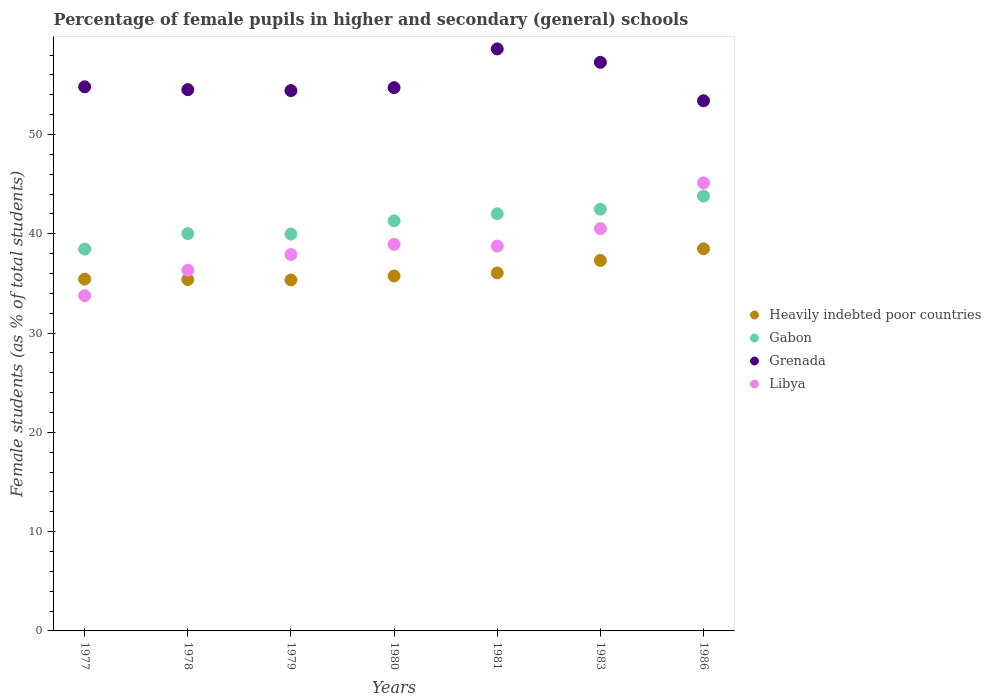Is the number of dotlines equal to the number of legend labels?
Give a very brief answer. Yes. What is the percentage of female pupils in higher and secondary schools in Gabon in 1986?
Keep it short and to the point. 43.79. Across all years, what is the maximum percentage of female pupils in higher and secondary schools in Libya?
Keep it short and to the point. 45.12. Across all years, what is the minimum percentage of female pupils in higher and secondary schools in Gabon?
Offer a very short reply. 38.45. In which year was the percentage of female pupils in higher and secondary schools in Libya minimum?
Give a very brief answer. 1977. What is the total percentage of female pupils in higher and secondary schools in Heavily indebted poor countries in the graph?
Your answer should be very brief. 253.76. What is the difference between the percentage of female pupils in higher and secondary schools in Libya in 1979 and that in 1981?
Ensure brevity in your answer.  -0.85. What is the difference between the percentage of female pupils in higher and secondary schools in Gabon in 1986 and the percentage of female pupils in higher and secondary schools in Grenada in 1977?
Your answer should be very brief. -11.01. What is the average percentage of female pupils in higher and secondary schools in Gabon per year?
Provide a succinct answer. 41.14. In the year 1986, what is the difference between the percentage of female pupils in higher and secondary schools in Grenada and percentage of female pupils in higher and secondary schools in Heavily indebted poor countries?
Your answer should be very brief. 14.9. In how many years, is the percentage of female pupils in higher and secondary schools in Heavily indebted poor countries greater than 2 %?
Your response must be concise. 7. What is the ratio of the percentage of female pupils in higher and secondary schools in Libya in 1979 to that in 1986?
Make the answer very short. 0.84. What is the difference between the highest and the second highest percentage of female pupils in higher and secondary schools in Heavily indebted poor countries?
Offer a very short reply. 1.17. What is the difference between the highest and the lowest percentage of female pupils in higher and secondary schools in Libya?
Give a very brief answer. 11.36. In how many years, is the percentage of female pupils in higher and secondary schools in Gabon greater than the average percentage of female pupils in higher and secondary schools in Gabon taken over all years?
Keep it short and to the point. 4. Is it the case that in every year, the sum of the percentage of female pupils in higher and secondary schools in Gabon and percentage of female pupils in higher and secondary schools in Libya  is greater than the sum of percentage of female pupils in higher and secondary schools in Heavily indebted poor countries and percentage of female pupils in higher and secondary schools in Grenada?
Provide a succinct answer. Yes. Is it the case that in every year, the sum of the percentage of female pupils in higher and secondary schools in Gabon and percentage of female pupils in higher and secondary schools in Heavily indebted poor countries  is greater than the percentage of female pupils in higher and secondary schools in Libya?
Your answer should be very brief. Yes. Does the percentage of female pupils in higher and secondary schools in Heavily indebted poor countries monotonically increase over the years?
Your answer should be very brief. No. Is the percentage of female pupils in higher and secondary schools in Heavily indebted poor countries strictly less than the percentage of female pupils in higher and secondary schools in Gabon over the years?
Provide a short and direct response. Yes. How many dotlines are there?
Make the answer very short. 4. What is the difference between two consecutive major ticks on the Y-axis?
Offer a terse response. 10. Does the graph contain any zero values?
Provide a succinct answer. No. Does the graph contain grids?
Give a very brief answer. No. How many legend labels are there?
Ensure brevity in your answer.  4. How are the legend labels stacked?
Make the answer very short. Vertical. What is the title of the graph?
Offer a terse response. Percentage of female pupils in higher and secondary (general) schools. Does "Greece" appear as one of the legend labels in the graph?
Make the answer very short. No. What is the label or title of the X-axis?
Offer a terse response. Years. What is the label or title of the Y-axis?
Offer a very short reply. Female students (as % of total students). What is the Female students (as % of total students) in Heavily indebted poor countries in 1977?
Make the answer very short. 35.43. What is the Female students (as % of total students) of Gabon in 1977?
Your answer should be very brief. 38.45. What is the Female students (as % of total students) of Grenada in 1977?
Provide a short and direct response. 54.8. What is the Female students (as % of total students) of Libya in 1977?
Keep it short and to the point. 33.76. What is the Female students (as % of total students) in Heavily indebted poor countries in 1978?
Ensure brevity in your answer.  35.39. What is the Female students (as % of total students) of Gabon in 1978?
Keep it short and to the point. 40.02. What is the Female students (as % of total students) of Grenada in 1978?
Your answer should be compact. 54.51. What is the Female students (as % of total students) in Libya in 1978?
Offer a terse response. 36.33. What is the Female students (as % of total students) in Heavily indebted poor countries in 1979?
Provide a succinct answer. 35.35. What is the Female students (as % of total students) of Gabon in 1979?
Make the answer very short. 39.97. What is the Female students (as % of total students) in Grenada in 1979?
Offer a very short reply. 54.41. What is the Female students (as % of total students) of Libya in 1979?
Your answer should be compact. 37.91. What is the Female students (as % of total students) of Heavily indebted poor countries in 1980?
Give a very brief answer. 35.75. What is the Female students (as % of total students) in Gabon in 1980?
Make the answer very short. 41.3. What is the Female students (as % of total students) in Grenada in 1980?
Offer a terse response. 54.71. What is the Female students (as % of total students) in Libya in 1980?
Make the answer very short. 38.93. What is the Female students (as % of total students) in Heavily indebted poor countries in 1981?
Offer a terse response. 36.05. What is the Female students (as % of total students) in Gabon in 1981?
Ensure brevity in your answer.  42.01. What is the Female students (as % of total students) of Grenada in 1981?
Provide a succinct answer. 58.61. What is the Female students (as % of total students) in Libya in 1981?
Your answer should be compact. 38.76. What is the Female students (as % of total students) in Heavily indebted poor countries in 1983?
Offer a terse response. 37.31. What is the Female students (as % of total students) in Gabon in 1983?
Ensure brevity in your answer.  42.47. What is the Female students (as % of total students) of Grenada in 1983?
Give a very brief answer. 57.26. What is the Female students (as % of total students) of Libya in 1983?
Your answer should be very brief. 40.51. What is the Female students (as % of total students) in Heavily indebted poor countries in 1986?
Your answer should be compact. 38.49. What is the Female students (as % of total students) in Gabon in 1986?
Provide a succinct answer. 43.79. What is the Female students (as % of total students) in Grenada in 1986?
Your response must be concise. 53.39. What is the Female students (as % of total students) in Libya in 1986?
Keep it short and to the point. 45.12. Across all years, what is the maximum Female students (as % of total students) in Heavily indebted poor countries?
Your answer should be very brief. 38.49. Across all years, what is the maximum Female students (as % of total students) of Gabon?
Your response must be concise. 43.79. Across all years, what is the maximum Female students (as % of total students) in Grenada?
Keep it short and to the point. 58.61. Across all years, what is the maximum Female students (as % of total students) in Libya?
Provide a succinct answer. 45.12. Across all years, what is the minimum Female students (as % of total students) in Heavily indebted poor countries?
Offer a terse response. 35.35. Across all years, what is the minimum Female students (as % of total students) of Gabon?
Provide a short and direct response. 38.45. Across all years, what is the minimum Female students (as % of total students) in Grenada?
Offer a terse response. 53.39. Across all years, what is the minimum Female students (as % of total students) of Libya?
Offer a terse response. 33.76. What is the total Female students (as % of total students) of Heavily indebted poor countries in the graph?
Provide a succinct answer. 253.76. What is the total Female students (as % of total students) in Gabon in the graph?
Provide a short and direct response. 288.01. What is the total Female students (as % of total students) of Grenada in the graph?
Your answer should be compact. 387.7. What is the total Female students (as % of total students) in Libya in the graph?
Keep it short and to the point. 271.32. What is the difference between the Female students (as % of total students) in Heavily indebted poor countries in 1977 and that in 1978?
Ensure brevity in your answer.  0.04. What is the difference between the Female students (as % of total students) of Gabon in 1977 and that in 1978?
Offer a terse response. -1.56. What is the difference between the Female students (as % of total students) in Grenada in 1977 and that in 1978?
Provide a succinct answer. 0.29. What is the difference between the Female students (as % of total students) in Libya in 1977 and that in 1978?
Make the answer very short. -2.56. What is the difference between the Female students (as % of total students) in Heavily indebted poor countries in 1977 and that in 1979?
Your answer should be very brief. 0.08. What is the difference between the Female students (as % of total students) of Gabon in 1977 and that in 1979?
Offer a very short reply. -1.51. What is the difference between the Female students (as % of total students) of Grenada in 1977 and that in 1979?
Provide a short and direct response. 0.38. What is the difference between the Female students (as % of total students) in Libya in 1977 and that in 1979?
Your response must be concise. -4.14. What is the difference between the Female students (as % of total students) in Heavily indebted poor countries in 1977 and that in 1980?
Provide a succinct answer. -0.32. What is the difference between the Female students (as % of total students) of Gabon in 1977 and that in 1980?
Your response must be concise. -2.84. What is the difference between the Female students (as % of total students) of Grenada in 1977 and that in 1980?
Provide a short and direct response. 0.09. What is the difference between the Female students (as % of total students) of Libya in 1977 and that in 1980?
Offer a terse response. -5.17. What is the difference between the Female students (as % of total students) of Heavily indebted poor countries in 1977 and that in 1981?
Provide a short and direct response. -0.62. What is the difference between the Female students (as % of total students) of Gabon in 1977 and that in 1981?
Keep it short and to the point. -3.56. What is the difference between the Female students (as % of total students) of Grenada in 1977 and that in 1981?
Keep it short and to the point. -3.82. What is the difference between the Female students (as % of total students) of Libya in 1977 and that in 1981?
Give a very brief answer. -4.99. What is the difference between the Female students (as % of total students) in Heavily indebted poor countries in 1977 and that in 1983?
Give a very brief answer. -1.88. What is the difference between the Female students (as % of total students) of Gabon in 1977 and that in 1983?
Ensure brevity in your answer.  -4.02. What is the difference between the Female students (as % of total students) of Grenada in 1977 and that in 1983?
Your answer should be compact. -2.46. What is the difference between the Female students (as % of total students) of Libya in 1977 and that in 1983?
Your answer should be very brief. -6.75. What is the difference between the Female students (as % of total students) of Heavily indebted poor countries in 1977 and that in 1986?
Give a very brief answer. -3.06. What is the difference between the Female students (as % of total students) of Gabon in 1977 and that in 1986?
Make the answer very short. -5.34. What is the difference between the Female students (as % of total students) in Grenada in 1977 and that in 1986?
Offer a very short reply. 1.41. What is the difference between the Female students (as % of total students) of Libya in 1977 and that in 1986?
Make the answer very short. -11.36. What is the difference between the Female students (as % of total students) of Heavily indebted poor countries in 1978 and that in 1979?
Your response must be concise. 0.04. What is the difference between the Female students (as % of total students) in Gabon in 1978 and that in 1979?
Give a very brief answer. 0.05. What is the difference between the Female students (as % of total students) in Grenada in 1978 and that in 1979?
Offer a very short reply. 0.1. What is the difference between the Female students (as % of total students) of Libya in 1978 and that in 1979?
Your answer should be very brief. -1.58. What is the difference between the Female students (as % of total students) of Heavily indebted poor countries in 1978 and that in 1980?
Your answer should be compact. -0.36. What is the difference between the Female students (as % of total students) of Gabon in 1978 and that in 1980?
Give a very brief answer. -1.28. What is the difference between the Female students (as % of total students) of Grenada in 1978 and that in 1980?
Provide a short and direct response. -0.2. What is the difference between the Female students (as % of total students) of Libya in 1978 and that in 1980?
Your response must be concise. -2.61. What is the difference between the Female students (as % of total students) of Heavily indebted poor countries in 1978 and that in 1981?
Offer a very short reply. -0.66. What is the difference between the Female students (as % of total students) of Gabon in 1978 and that in 1981?
Offer a terse response. -2. What is the difference between the Female students (as % of total students) of Grenada in 1978 and that in 1981?
Ensure brevity in your answer.  -4.1. What is the difference between the Female students (as % of total students) of Libya in 1978 and that in 1981?
Your answer should be very brief. -2.43. What is the difference between the Female students (as % of total students) of Heavily indebted poor countries in 1978 and that in 1983?
Ensure brevity in your answer.  -1.92. What is the difference between the Female students (as % of total students) of Gabon in 1978 and that in 1983?
Make the answer very short. -2.45. What is the difference between the Female students (as % of total students) in Grenada in 1978 and that in 1983?
Your response must be concise. -2.75. What is the difference between the Female students (as % of total students) in Libya in 1978 and that in 1983?
Provide a short and direct response. -4.19. What is the difference between the Female students (as % of total students) in Heavily indebted poor countries in 1978 and that in 1986?
Keep it short and to the point. -3.1. What is the difference between the Female students (as % of total students) of Gabon in 1978 and that in 1986?
Your response must be concise. -3.78. What is the difference between the Female students (as % of total students) in Grenada in 1978 and that in 1986?
Ensure brevity in your answer.  1.12. What is the difference between the Female students (as % of total students) of Libya in 1978 and that in 1986?
Your answer should be compact. -8.8. What is the difference between the Female students (as % of total students) in Heavily indebted poor countries in 1979 and that in 1980?
Offer a very short reply. -0.4. What is the difference between the Female students (as % of total students) of Gabon in 1979 and that in 1980?
Make the answer very short. -1.33. What is the difference between the Female students (as % of total students) of Grenada in 1979 and that in 1980?
Offer a very short reply. -0.3. What is the difference between the Female students (as % of total students) in Libya in 1979 and that in 1980?
Provide a succinct answer. -1.03. What is the difference between the Female students (as % of total students) of Heavily indebted poor countries in 1979 and that in 1981?
Your response must be concise. -0.7. What is the difference between the Female students (as % of total students) in Gabon in 1979 and that in 1981?
Ensure brevity in your answer.  -2.05. What is the difference between the Female students (as % of total students) of Grenada in 1979 and that in 1981?
Provide a short and direct response. -4.2. What is the difference between the Female students (as % of total students) in Libya in 1979 and that in 1981?
Your response must be concise. -0.85. What is the difference between the Female students (as % of total students) in Heavily indebted poor countries in 1979 and that in 1983?
Your answer should be very brief. -1.96. What is the difference between the Female students (as % of total students) in Gabon in 1979 and that in 1983?
Your answer should be compact. -2.5. What is the difference between the Female students (as % of total students) in Grenada in 1979 and that in 1983?
Make the answer very short. -2.85. What is the difference between the Female students (as % of total students) in Libya in 1979 and that in 1983?
Provide a short and direct response. -2.61. What is the difference between the Female students (as % of total students) of Heavily indebted poor countries in 1979 and that in 1986?
Your answer should be very brief. -3.14. What is the difference between the Female students (as % of total students) of Gabon in 1979 and that in 1986?
Your response must be concise. -3.82. What is the difference between the Female students (as % of total students) of Grenada in 1979 and that in 1986?
Keep it short and to the point. 1.02. What is the difference between the Female students (as % of total students) of Libya in 1979 and that in 1986?
Provide a short and direct response. -7.22. What is the difference between the Female students (as % of total students) in Heavily indebted poor countries in 1980 and that in 1981?
Give a very brief answer. -0.3. What is the difference between the Female students (as % of total students) of Gabon in 1980 and that in 1981?
Your response must be concise. -0.72. What is the difference between the Female students (as % of total students) of Grenada in 1980 and that in 1981?
Offer a very short reply. -3.9. What is the difference between the Female students (as % of total students) of Libya in 1980 and that in 1981?
Your response must be concise. 0.17. What is the difference between the Female students (as % of total students) of Heavily indebted poor countries in 1980 and that in 1983?
Make the answer very short. -1.56. What is the difference between the Female students (as % of total students) of Gabon in 1980 and that in 1983?
Provide a succinct answer. -1.17. What is the difference between the Female students (as % of total students) of Grenada in 1980 and that in 1983?
Keep it short and to the point. -2.55. What is the difference between the Female students (as % of total students) of Libya in 1980 and that in 1983?
Offer a terse response. -1.58. What is the difference between the Female students (as % of total students) of Heavily indebted poor countries in 1980 and that in 1986?
Keep it short and to the point. -2.74. What is the difference between the Female students (as % of total students) of Gabon in 1980 and that in 1986?
Give a very brief answer. -2.49. What is the difference between the Female students (as % of total students) in Grenada in 1980 and that in 1986?
Offer a terse response. 1.32. What is the difference between the Female students (as % of total students) of Libya in 1980 and that in 1986?
Your answer should be compact. -6.19. What is the difference between the Female students (as % of total students) in Heavily indebted poor countries in 1981 and that in 1983?
Your answer should be very brief. -1.26. What is the difference between the Female students (as % of total students) of Gabon in 1981 and that in 1983?
Make the answer very short. -0.46. What is the difference between the Female students (as % of total students) of Grenada in 1981 and that in 1983?
Your response must be concise. 1.35. What is the difference between the Female students (as % of total students) of Libya in 1981 and that in 1983?
Offer a very short reply. -1.76. What is the difference between the Female students (as % of total students) in Heavily indebted poor countries in 1981 and that in 1986?
Give a very brief answer. -2.43. What is the difference between the Female students (as % of total students) of Gabon in 1981 and that in 1986?
Ensure brevity in your answer.  -1.78. What is the difference between the Female students (as % of total students) in Grenada in 1981 and that in 1986?
Your response must be concise. 5.22. What is the difference between the Female students (as % of total students) in Libya in 1981 and that in 1986?
Your answer should be compact. -6.37. What is the difference between the Female students (as % of total students) in Heavily indebted poor countries in 1983 and that in 1986?
Provide a succinct answer. -1.17. What is the difference between the Female students (as % of total students) of Gabon in 1983 and that in 1986?
Offer a very short reply. -1.32. What is the difference between the Female students (as % of total students) in Grenada in 1983 and that in 1986?
Your answer should be very brief. 3.87. What is the difference between the Female students (as % of total students) in Libya in 1983 and that in 1986?
Make the answer very short. -4.61. What is the difference between the Female students (as % of total students) of Heavily indebted poor countries in 1977 and the Female students (as % of total students) of Gabon in 1978?
Give a very brief answer. -4.59. What is the difference between the Female students (as % of total students) in Heavily indebted poor countries in 1977 and the Female students (as % of total students) in Grenada in 1978?
Offer a very short reply. -19.08. What is the difference between the Female students (as % of total students) of Heavily indebted poor countries in 1977 and the Female students (as % of total students) of Libya in 1978?
Provide a short and direct response. -0.9. What is the difference between the Female students (as % of total students) in Gabon in 1977 and the Female students (as % of total students) in Grenada in 1978?
Provide a succinct answer. -16.06. What is the difference between the Female students (as % of total students) in Gabon in 1977 and the Female students (as % of total students) in Libya in 1978?
Provide a short and direct response. 2.13. What is the difference between the Female students (as % of total students) in Grenada in 1977 and the Female students (as % of total students) in Libya in 1978?
Offer a very short reply. 18.47. What is the difference between the Female students (as % of total students) in Heavily indebted poor countries in 1977 and the Female students (as % of total students) in Gabon in 1979?
Ensure brevity in your answer.  -4.54. What is the difference between the Female students (as % of total students) in Heavily indebted poor countries in 1977 and the Female students (as % of total students) in Grenada in 1979?
Your answer should be compact. -18.99. What is the difference between the Female students (as % of total students) in Heavily indebted poor countries in 1977 and the Female students (as % of total students) in Libya in 1979?
Offer a very short reply. -2.48. What is the difference between the Female students (as % of total students) in Gabon in 1977 and the Female students (as % of total students) in Grenada in 1979?
Ensure brevity in your answer.  -15.96. What is the difference between the Female students (as % of total students) in Gabon in 1977 and the Female students (as % of total students) in Libya in 1979?
Give a very brief answer. 0.55. What is the difference between the Female students (as % of total students) in Grenada in 1977 and the Female students (as % of total students) in Libya in 1979?
Offer a very short reply. 16.89. What is the difference between the Female students (as % of total students) in Heavily indebted poor countries in 1977 and the Female students (as % of total students) in Gabon in 1980?
Your answer should be compact. -5.87. What is the difference between the Female students (as % of total students) of Heavily indebted poor countries in 1977 and the Female students (as % of total students) of Grenada in 1980?
Offer a terse response. -19.28. What is the difference between the Female students (as % of total students) in Heavily indebted poor countries in 1977 and the Female students (as % of total students) in Libya in 1980?
Provide a succinct answer. -3.5. What is the difference between the Female students (as % of total students) in Gabon in 1977 and the Female students (as % of total students) in Grenada in 1980?
Your response must be concise. -16.26. What is the difference between the Female students (as % of total students) of Gabon in 1977 and the Female students (as % of total students) of Libya in 1980?
Your answer should be compact. -0.48. What is the difference between the Female students (as % of total students) of Grenada in 1977 and the Female students (as % of total students) of Libya in 1980?
Your response must be concise. 15.87. What is the difference between the Female students (as % of total students) of Heavily indebted poor countries in 1977 and the Female students (as % of total students) of Gabon in 1981?
Your answer should be very brief. -6.59. What is the difference between the Female students (as % of total students) of Heavily indebted poor countries in 1977 and the Female students (as % of total students) of Grenada in 1981?
Your answer should be very brief. -23.19. What is the difference between the Female students (as % of total students) in Heavily indebted poor countries in 1977 and the Female students (as % of total students) in Libya in 1981?
Provide a short and direct response. -3.33. What is the difference between the Female students (as % of total students) in Gabon in 1977 and the Female students (as % of total students) in Grenada in 1981?
Your answer should be compact. -20.16. What is the difference between the Female students (as % of total students) of Gabon in 1977 and the Female students (as % of total students) of Libya in 1981?
Make the answer very short. -0.3. What is the difference between the Female students (as % of total students) in Grenada in 1977 and the Female students (as % of total students) in Libya in 1981?
Your answer should be very brief. 16.04. What is the difference between the Female students (as % of total students) in Heavily indebted poor countries in 1977 and the Female students (as % of total students) in Gabon in 1983?
Ensure brevity in your answer.  -7.04. What is the difference between the Female students (as % of total students) in Heavily indebted poor countries in 1977 and the Female students (as % of total students) in Grenada in 1983?
Offer a very short reply. -21.84. What is the difference between the Female students (as % of total students) of Heavily indebted poor countries in 1977 and the Female students (as % of total students) of Libya in 1983?
Your response must be concise. -5.09. What is the difference between the Female students (as % of total students) of Gabon in 1977 and the Female students (as % of total students) of Grenada in 1983?
Offer a very short reply. -18.81. What is the difference between the Female students (as % of total students) in Gabon in 1977 and the Female students (as % of total students) in Libya in 1983?
Make the answer very short. -2.06. What is the difference between the Female students (as % of total students) in Grenada in 1977 and the Female students (as % of total students) in Libya in 1983?
Your answer should be very brief. 14.28. What is the difference between the Female students (as % of total students) in Heavily indebted poor countries in 1977 and the Female students (as % of total students) in Gabon in 1986?
Your answer should be compact. -8.36. What is the difference between the Female students (as % of total students) in Heavily indebted poor countries in 1977 and the Female students (as % of total students) in Grenada in 1986?
Your answer should be compact. -17.96. What is the difference between the Female students (as % of total students) in Heavily indebted poor countries in 1977 and the Female students (as % of total students) in Libya in 1986?
Give a very brief answer. -9.69. What is the difference between the Female students (as % of total students) of Gabon in 1977 and the Female students (as % of total students) of Grenada in 1986?
Offer a terse response. -14.94. What is the difference between the Female students (as % of total students) of Gabon in 1977 and the Female students (as % of total students) of Libya in 1986?
Keep it short and to the point. -6.67. What is the difference between the Female students (as % of total students) in Grenada in 1977 and the Female students (as % of total students) in Libya in 1986?
Your answer should be compact. 9.68. What is the difference between the Female students (as % of total students) of Heavily indebted poor countries in 1978 and the Female students (as % of total students) of Gabon in 1979?
Ensure brevity in your answer.  -4.58. What is the difference between the Female students (as % of total students) in Heavily indebted poor countries in 1978 and the Female students (as % of total students) in Grenada in 1979?
Your answer should be very brief. -19.03. What is the difference between the Female students (as % of total students) of Heavily indebted poor countries in 1978 and the Female students (as % of total students) of Libya in 1979?
Give a very brief answer. -2.52. What is the difference between the Female students (as % of total students) of Gabon in 1978 and the Female students (as % of total students) of Grenada in 1979?
Offer a very short reply. -14.4. What is the difference between the Female students (as % of total students) of Gabon in 1978 and the Female students (as % of total students) of Libya in 1979?
Keep it short and to the point. 2.11. What is the difference between the Female students (as % of total students) of Grenada in 1978 and the Female students (as % of total students) of Libya in 1979?
Your response must be concise. 16.61. What is the difference between the Female students (as % of total students) in Heavily indebted poor countries in 1978 and the Female students (as % of total students) in Gabon in 1980?
Your response must be concise. -5.91. What is the difference between the Female students (as % of total students) of Heavily indebted poor countries in 1978 and the Female students (as % of total students) of Grenada in 1980?
Your answer should be compact. -19.32. What is the difference between the Female students (as % of total students) of Heavily indebted poor countries in 1978 and the Female students (as % of total students) of Libya in 1980?
Your answer should be compact. -3.54. What is the difference between the Female students (as % of total students) in Gabon in 1978 and the Female students (as % of total students) in Grenada in 1980?
Give a very brief answer. -14.7. What is the difference between the Female students (as % of total students) of Gabon in 1978 and the Female students (as % of total students) of Libya in 1980?
Your answer should be compact. 1.08. What is the difference between the Female students (as % of total students) of Grenada in 1978 and the Female students (as % of total students) of Libya in 1980?
Offer a terse response. 15.58. What is the difference between the Female students (as % of total students) in Heavily indebted poor countries in 1978 and the Female students (as % of total students) in Gabon in 1981?
Provide a succinct answer. -6.63. What is the difference between the Female students (as % of total students) of Heavily indebted poor countries in 1978 and the Female students (as % of total students) of Grenada in 1981?
Offer a terse response. -23.23. What is the difference between the Female students (as % of total students) of Heavily indebted poor countries in 1978 and the Female students (as % of total students) of Libya in 1981?
Give a very brief answer. -3.37. What is the difference between the Female students (as % of total students) in Gabon in 1978 and the Female students (as % of total students) in Grenada in 1981?
Make the answer very short. -18.6. What is the difference between the Female students (as % of total students) in Gabon in 1978 and the Female students (as % of total students) in Libya in 1981?
Offer a terse response. 1.26. What is the difference between the Female students (as % of total students) in Grenada in 1978 and the Female students (as % of total students) in Libya in 1981?
Provide a succinct answer. 15.75. What is the difference between the Female students (as % of total students) of Heavily indebted poor countries in 1978 and the Female students (as % of total students) of Gabon in 1983?
Your response must be concise. -7.08. What is the difference between the Female students (as % of total students) in Heavily indebted poor countries in 1978 and the Female students (as % of total students) in Grenada in 1983?
Offer a terse response. -21.87. What is the difference between the Female students (as % of total students) in Heavily indebted poor countries in 1978 and the Female students (as % of total students) in Libya in 1983?
Provide a short and direct response. -5.13. What is the difference between the Female students (as % of total students) of Gabon in 1978 and the Female students (as % of total students) of Grenada in 1983?
Give a very brief answer. -17.25. What is the difference between the Female students (as % of total students) of Gabon in 1978 and the Female students (as % of total students) of Libya in 1983?
Make the answer very short. -0.5. What is the difference between the Female students (as % of total students) of Grenada in 1978 and the Female students (as % of total students) of Libya in 1983?
Give a very brief answer. 14. What is the difference between the Female students (as % of total students) of Heavily indebted poor countries in 1978 and the Female students (as % of total students) of Gabon in 1986?
Give a very brief answer. -8.4. What is the difference between the Female students (as % of total students) of Heavily indebted poor countries in 1978 and the Female students (as % of total students) of Grenada in 1986?
Make the answer very short. -18. What is the difference between the Female students (as % of total students) of Heavily indebted poor countries in 1978 and the Female students (as % of total students) of Libya in 1986?
Offer a very short reply. -9.73. What is the difference between the Female students (as % of total students) in Gabon in 1978 and the Female students (as % of total students) in Grenada in 1986?
Provide a succinct answer. -13.37. What is the difference between the Female students (as % of total students) in Gabon in 1978 and the Female students (as % of total students) in Libya in 1986?
Ensure brevity in your answer.  -5.11. What is the difference between the Female students (as % of total students) in Grenada in 1978 and the Female students (as % of total students) in Libya in 1986?
Offer a terse response. 9.39. What is the difference between the Female students (as % of total students) in Heavily indebted poor countries in 1979 and the Female students (as % of total students) in Gabon in 1980?
Offer a very short reply. -5.95. What is the difference between the Female students (as % of total students) of Heavily indebted poor countries in 1979 and the Female students (as % of total students) of Grenada in 1980?
Your answer should be very brief. -19.36. What is the difference between the Female students (as % of total students) of Heavily indebted poor countries in 1979 and the Female students (as % of total students) of Libya in 1980?
Your answer should be very brief. -3.58. What is the difference between the Female students (as % of total students) in Gabon in 1979 and the Female students (as % of total students) in Grenada in 1980?
Give a very brief answer. -14.74. What is the difference between the Female students (as % of total students) in Gabon in 1979 and the Female students (as % of total students) in Libya in 1980?
Ensure brevity in your answer.  1.04. What is the difference between the Female students (as % of total students) in Grenada in 1979 and the Female students (as % of total students) in Libya in 1980?
Keep it short and to the point. 15.48. What is the difference between the Female students (as % of total students) of Heavily indebted poor countries in 1979 and the Female students (as % of total students) of Gabon in 1981?
Your answer should be compact. -6.67. What is the difference between the Female students (as % of total students) of Heavily indebted poor countries in 1979 and the Female students (as % of total students) of Grenada in 1981?
Make the answer very short. -23.27. What is the difference between the Female students (as % of total students) in Heavily indebted poor countries in 1979 and the Female students (as % of total students) in Libya in 1981?
Offer a terse response. -3.41. What is the difference between the Female students (as % of total students) in Gabon in 1979 and the Female students (as % of total students) in Grenada in 1981?
Your response must be concise. -18.65. What is the difference between the Female students (as % of total students) in Gabon in 1979 and the Female students (as % of total students) in Libya in 1981?
Your answer should be very brief. 1.21. What is the difference between the Female students (as % of total students) in Grenada in 1979 and the Female students (as % of total students) in Libya in 1981?
Give a very brief answer. 15.66. What is the difference between the Female students (as % of total students) of Heavily indebted poor countries in 1979 and the Female students (as % of total students) of Gabon in 1983?
Your answer should be compact. -7.12. What is the difference between the Female students (as % of total students) of Heavily indebted poor countries in 1979 and the Female students (as % of total students) of Grenada in 1983?
Your response must be concise. -21.91. What is the difference between the Female students (as % of total students) of Heavily indebted poor countries in 1979 and the Female students (as % of total students) of Libya in 1983?
Provide a short and direct response. -5.17. What is the difference between the Female students (as % of total students) in Gabon in 1979 and the Female students (as % of total students) in Grenada in 1983?
Make the answer very short. -17.3. What is the difference between the Female students (as % of total students) in Gabon in 1979 and the Female students (as % of total students) in Libya in 1983?
Your answer should be very brief. -0.55. What is the difference between the Female students (as % of total students) in Grenada in 1979 and the Female students (as % of total students) in Libya in 1983?
Provide a short and direct response. 13.9. What is the difference between the Female students (as % of total students) in Heavily indebted poor countries in 1979 and the Female students (as % of total students) in Gabon in 1986?
Keep it short and to the point. -8.44. What is the difference between the Female students (as % of total students) in Heavily indebted poor countries in 1979 and the Female students (as % of total students) in Grenada in 1986?
Keep it short and to the point. -18.04. What is the difference between the Female students (as % of total students) in Heavily indebted poor countries in 1979 and the Female students (as % of total students) in Libya in 1986?
Make the answer very short. -9.77. What is the difference between the Female students (as % of total students) of Gabon in 1979 and the Female students (as % of total students) of Grenada in 1986?
Give a very brief answer. -13.42. What is the difference between the Female students (as % of total students) of Gabon in 1979 and the Female students (as % of total students) of Libya in 1986?
Keep it short and to the point. -5.15. What is the difference between the Female students (as % of total students) of Grenada in 1979 and the Female students (as % of total students) of Libya in 1986?
Provide a succinct answer. 9.29. What is the difference between the Female students (as % of total students) in Heavily indebted poor countries in 1980 and the Female students (as % of total students) in Gabon in 1981?
Keep it short and to the point. -6.27. What is the difference between the Female students (as % of total students) in Heavily indebted poor countries in 1980 and the Female students (as % of total students) in Grenada in 1981?
Your response must be concise. -22.87. What is the difference between the Female students (as % of total students) of Heavily indebted poor countries in 1980 and the Female students (as % of total students) of Libya in 1981?
Give a very brief answer. -3.01. What is the difference between the Female students (as % of total students) of Gabon in 1980 and the Female students (as % of total students) of Grenada in 1981?
Your answer should be compact. -17.32. What is the difference between the Female students (as % of total students) in Gabon in 1980 and the Female students (as % of total students) in Libya in 1981?
Offer a terse response. 2.54. What is the difference between the Female students (as % of total students) of Grenada in 1980 and the Female students (as % of total students) of Libya in 1981?
Your answer should be compact. 15.95. What is the difference between the Female students (as % of total students) of Heavily indebted poor countries in 1980 and the Female students (as % of total students) of Gabon in 1983?
Offer a very short reply. -6.72. What is the difference between the Female students (as % of total students) of Heavily indebted poor countries in 1980 and the Female students (as % of total students) of Grenada in 1983?
Provide a short and direct response. -21.51. What is the difference between the Female students (as % of total students) of Heavily indebted poor countries in 1980 and the Female students (as % of total students) of Libya in 1983?
Your response must be concise. -4.77. What is the difference between the Female students (as % of total students) in Gabon in 1980 and the Female students (as % of total students) in Grenada in 1983?
Ensure brevity in your answer.  -15.97. What is the difference between the Female students (as % of total students) in Gabon in 1980 and the Female students (as % of total students) in Libya in 1983?
Provide a succinct answer. 0.78. What is the difference between the Female students (as % of total students) in Grenada in 1980 and the Female students (as % of total students) in Libya in 1983?
Offer a terse response. 14.2. What is the difference between the Female students (as % of total students) of Heavily indebted poor countries in 1980 and the Female students (as % of total students) of Gabon in 1986?
Your answer should be compact. -8.04. What is the difference between the Female students (as % of total students) of Heavily indebted poor countries in 1980 and the Female students (as % of total students) of Grenada in 1986?
Make the answer very short. -17.64. What is the difference between the Female students (as % of total students) of Heavily indebted poor countries in 1980 and the Female students (as % of total students) of Libya in 1986?
Your answer should be compact. -9.37. What is the difference between the Female students (as % of total students) of Gabon in 1980 and the Female students (as % of total students) of Grenada in 1986?
Your answer should be very brief. -12.09. What is the difference between the Female students (as % of total students) in Gabon in 1980 and the Female students (as % of total students) in Libya in 1986?
Offer a terse response. -3.82. What is the difference between the Female students (as % of total students) of Grenada in 1980 and the Female students (as % of total students) of Libya in 1986?
Provide a short and direct response. 9.59. What is the difference between the Female students (as % of total students) in Heavily indebted poor countries in 1981 and the Female students (as % of total students) in Gabon in 1983?
Provide a short and direct response. -6.42. What is the difference between the Female students (as % of total students) of Heavily indebted poor countries in 1981 and the Female students (as % of total students) of Grenada in 1983?
Provide a short and direct response. -21.21. What is the difference between the Female students (as % of total students) in Heavily indebted poor countries in 1981 and the Female students (as % of total students) in Libya in 1983?
Give a very brief answer. -4.46. What is the difference between the Female students (as % of total students) in Gabon in 1981 and the Female students (as % of total students) in Grenada in 1983?
Ensure brevity in your answer.  -15.25. What is the difference between the Female students (as % of total students) in Gabon in 1981 and the Female students (as % of total students) in Libya in 1983?
Give a very brief answer. 1.5. What is the difference between the Female students (as % of total students) of Grenada in 1981 and the Female students (as % of total students) of Libya in 1983?
Provide a short and direct response. 18.1. What is the difference between the Female students (as % of total students) of Heavily indebted poor countries in 1981 and the Female students (as % of total students) of Gabon in 1986?
Make the answer very short. -7.74. What is the difference between the Female students (as % of total students) in Heavily indebted poor countries in 1981 and the Female students (as % of total students) in Grenada in 1986?
Give a very brief answer. -17.34. What is the difference between the Female students (as % of total students) of Heavily indebted poor countries in 1981 and the Female students (as % of total students) of Libya in 1986?
Make the answer very short. -9.07. What is the difference between the Female students (as % of total students) of Gabon in 1981 and the Female students (as % of total students) of Grenada in 1986?
Offer a very short reply. -11.38. What is the difference between the Female students (as % of total students) of Gabon in 1981 and the Female students (as % of total students) of Libya in 1986?
Keep it short and to the point. -3.11. What is the difference between the Female students (as % of total students) of Grenada in 1981 and the Female students (as % of total students) of Libya in 1986?
Make the answer very short. 13.49. What is the difference between the Female students (as % of total students) in Heavily indebted poor countries in 1983 and the Female students (as % of total students) in Gabon in 1986?
Your answer should be very brief. -6.48. What is the difference between the Female students (as % of total students) in Heavily indebted poor countries in 1983 and the Female students (as % of total students) in Grenada in 1986?
Your answer should be very brief. -16.08. What is the difference between the Female students (as % of total students) of Heavily indebted poor countries in 1983 and the Female students (as % of total students) of Libya in 1986?
Give a very brief answer. -7.81. What is the difference between the Female students (as % of total students) of Gabon in 1983 and the Female students (as % of total students) of Grenada in 1986?
Make the answer very short. -10.92. What is the difference between the Female students (as % of total students) of Gabon in 1983 and the Female students (as % of total students) of Libya in 1986?
Ensure brevity in your answer.  -2.65. What is the difference between the Female students (as % of total students) in Grenada in 1983 and the Female students (as % of total students) in Libya in 1986?
Provide a short and direct response. 12.14. What is the average Female students (as % of total students) of Heavily indebted poor countries per year?
Make the answer very short. 36.25. What is the average Female students (as % of total students) of Gabon per year?
Offer a terse response. 41.14. What is the average Female students (as % of total students) in Grenada per year?
Provide a short and direct response. 55.39. What is the average Female students (as % of total students) in Libya per year?
Provide a succinct answer. 38.76. In the year 1977, what is the difference between the Female students (as % of total students) of Heavily indebted poor countries and Female students (as % of total students) of Gabon?
Provide a succinct answer. -3.03. In the year 1977, what is the difference between the Female students (as % of total students) of Heavily indebted poor countries and Female students (as % of total students) of Grenada?
Your answer should be very brief. -19.37. In the year 1977, what is the difference between the Female students (as % of total students) of Heavily indebted poor countries and Female students (as % of total students) of Libya?
Provide a succinct answer. 1.66. In the year 1977, what is the difference between the Female students (as % of total students) in Gabon and Female students (as % of total students) in Grenada?
Offer a very short reply. -16.34. In the year 1977, what is the difference between the Female students (as % of total students) of Gabon and Female students (as % of total students) of Libya?
Offer a terse response. 4.69. In the year 1977, what is the difference between the Female students (as % of total students) of Grenada and Female students (as % of total students) of Libya?
Your answer should be compact. 21.03. In the year 1978, what is the difference between the Female students (as % of total students) of Heavily indebted poor countries and Female students (as % of total students) of Gabon?
Your answer should be very brief. -4.63. In the year 1978, what is the difference between the Female students (as % of total students) in Heavily indebted poor countries and Female students (as % of total students) in Grenada?
Provide a short and direct response. -19.12. In the year 1978, what is the difference between the Female students (as % of total students) in Heavily indebted poor countries and Female students (as % of total students) in Libya?
Ensure brevity in your answer.  -0.94. In the year 1978, what is the difference between the Female students (as % of total students) of Gabon and Female students (as % of total students) of Grenada?
Give a very brief answer. -14.49. In the year 1978, what is the difference between the Female students (as % of total students) in Gabon and Female students (as % of total students) in Libya?
Provide a short and direct response. 3.69. In the year 1978, what is the difference between the Female students (as % of total students) of Grenada and Female students (as % of total students) of Libya?
Make the answer very short. 18.18. In the year 1979, what is the difference between the Female students (as % of total students) in Heavily indebted poor countries and Female students (as % of total students) in Gabon?
Give a very brief answer. -4.62. In the year 1979, what is the difference between the Female students (as % of total students) in Heavily indebted poor countries and Female students (as % of total students) in Grenada?
Your answer should be very brief. -19.07. In the year 1979, what is the difference between the Female students (as % of total students) of Heavily indebted poor countries and Female students (as % of total students) of Libya?
Keep it short and to the point. -2.56. In the year 1979, what is the difference between the Female students (as % of total students) of Gabon and Female students (as % of total students) of Grenada?
Your answer should be compact. -14.45. In the year 1979, what is the difference between the Female students (as % of total students) in Gabon and Female students (as % of total students) in Libya?
Offer a terse response. 2.06. In the year 1979, what is the difference between the Female students (as % of total students) in Grenada and Female students (as % of total students) in Libya?
Give a very brief answer. 16.51. In the year 1980, what is the difference between the Female students (as % of total students) of Heavily indebted poor countries and Female students (as % of total students) of Gabon?
Your answer should be very brief. -5.55. In the year 1980, what is the difference between the Female students (as % of total students) of Heavily indebted poor countries and Female students (as % of total students) of Grenada?
Offer a terse response. -18.96. In the year 1980, what is the difference between the Female students (as % of total students) in Heavily indebted poor countries and Female students (as % of total students) in Libya?
Ensure brevity in your answer.  -3.18. In the year 1980, what is the difference between the Female students (as % of total students) of Gabon and Female students (as % of total students) of Grenada?
Your answer should be very brief. -13.41. In the year 1980, what is the difference between the Female students (as % of total students) of Gabon and Female students (as % of total students) of Libya?
Keep it short and to the point. 2.37. In the year 1980, what is the difference between the Female students (as % of total students) in Grenada and Female students (as % of total students) in Libya?
Ensure brevity in your answer.  15.78. In the year 1981, what is the difference between the Female students (as % of total students) of Heavily indebted poor countries and Female students (as % of total students) of Gabon?
Ensure brevity in your answer.  -5.96. In the year 1981, what is the difference between the Female students (as % of total students) of Heavily indebted poor countries and Female students (as % of total students) of Grenada?
Offer a terse response. -22.56. In the year 1981, what is the difference between the Female students (as % of total students) in Heavily indebted poor countries and Female students (as % of total students) in Libya?
Your response must be concise. -2.71. In the year 1981, what is the difference between the Female students (as % of total students) in Gabon and Female students (as % of total students) in Grenada?
Your response must be concise. -16.6. In the year 1981, what is the difference between the Female students (as % of total students) in Gabon and Female students (as % of total students) in Libya?
Keep it short and to the point. 3.26. In the year 1981, what is the difference between the Female students (as % of total students) in Grenada and Female students (as % of total students) in Libya?
Your answer should be very brief. 19.86. In the year 1983, what is the difference between the Female students (as % of total students) in Heavily indebted poor countries and Female students (as % of total students) in Gabon?
Your answer should be compact. -5.16. In the year 1983, what is the difference between the Female students (as % of total students) in Heavily indebted poor countries and Female students (as % of total students) in Grenada?
Your answer should be compact. -19.95. In the year 1983, what is the difference between the Female students (as % of total students) of Heavily indebted poor countries and Female students (as % of total students) of Libya?
Your answer should be very brief. -3.2. In the year 1983, what is the difference between the Female students (as % of total students) in Gabon and Female students (as % of total students) in Grenada?
Ensure brevity in your answer.  -14.79. In the year 1983, what is the difference between the Female students (as % of total students) in Gabon and Female students (as % of total students) in Libya?
Keep it short and to the point. 1.96. In the year 1983, what is the difference between the Female students (as % of total students) of Grenada and Female students (as % of total students) of Libya?
Provide a short and direct response. 16.75. In the year 1986, what is the difference between the Female students (as % of total students) of Heavily indebted poor countries and Female students (as % of total students) of Gabon?
Your response must be concise. -5.31. In the year 1986, what is the difference between the Female students (as % of total students) of Heavily indebted poor countries and Female students (as % of total students) of Grenada?
Make the answer very short. -14.9. In the year 1986, what is the difference between the Female students (as % of total students) of Heavily indebted poor countries and Female students (as % of total students) of Libya?
Ensure brevity in your answer.  -6.64. In the year 1986, what is the difference between the Female students (as % of total students) in Gabon and Female students (as % of total students) in Grenada?
Make the answer very short. -9.6. In the year 1986, what is the difference between the Female students (as % of total students) in Gabon and Female students (as % of total students) in Libya?
Provide a succinct answer. -1.33. In the year 1986, what is the difference between the Female students (as % of total students) of Grenada and Female students (as % of total students) of Libya?
Give a very brief answer. 8.27. What is the ratio of the Female students (as % of total students) in Heavily indebted poor countries in 1977 to that in 1978?
Make the answer very short. 1. What is the ratio of the Female students (as % of total students) in Gabon in 1977 to that in 1978?
Your answer should be very brief. 0.96. What is the ratio of the Female students (as % of total students) in Grenada in 1977 to that in 1978?
Your response must be concise. 1.01. What is the ratio of the Female students (as % of total students) in Libya in 1977 to that in 1978?
Offer a terse response. 0.93. What is the ratio of the Female students (as % of total students) of Gabon in 1977 to that in 1979?
Give a very brief answer. 0.96. What is the ratio of the Female students (as % of total students) of Libya in 1977 to that in 1979?
Provide a succinct answer. 0.89. What is the ratio of the Female students (as % of total students) in Heavily indebted poor countries in 1977 to that in 1980?
Provide a short and direct response. 0.99. What is the ratio of the Female students (as % of total students) of Gabon in 1977 to that in 1980?
Keep it short and to the point. 0.93. What is the ratio of the Female students (as % of total students) in Libya in 1977 to that in 1980?
Make the answer very short. 0.87. What is the ratio of the Female students (as % of total students) of Heavily indebted poor countries in 1977 to that in 1981?
Your response must be concise. 0.98. What is the ratio of the Female students (as % of total students) in Gabon in 1977 to that in 1981?
Your response must be concise. 0.92. What is the ratio of the Female students (as % of total students) of Grenada in 1977 to that in 1981?
Your answer should be very brief. 0.93. What is the ratio of the Female students (as % of total students) in Libya in 1977 to that in 1981?
Ensure brevity in your answer.  0.87. What is the ratio of the Female students (as % of total students) of Heavily indebted poor countries in 1977 to that in 1983?
Your response must be concise. 0.95. What is the ratio of the Female students (as % of total students) of Gabon in 1977 to that in 1983?
Your answer should be very brief. 0.91. What is the ratio of the Female students (as % of total students) of Libya in 1977 to that in 1983?
Give a very brief answer. 0.83. What is the ratio of the Female students (as % of total students) in Heavily indebted poor countries in 1977 to that in 1986?
Your response must be concise. 0.92. What is the ratio of the Female students (as % of total students) of Gabon in 1977 to that in 1986?
Give a very brief answer. 0.88. What is the ratio of the Female students (as % of total students) of Grenada in 1977 to that in 1986?
Provide a succinct answer. 1.03. What is the ratio of the Female students (as % of total students) of Libya in 1977 to that in 1986?
Your answer should be very brief. 0.75. What is the ratio of the Female students (as % of total students) in Gabon in 1978 to that in 1979?
Provide a succinct answer. 1. What is the ratio of the Female students (as % of total students) of Grenada in 1978 to that in 1979?
Make the answer very short. 1. What is the ratio of the Female students (as % of total students) in Libya in 1978 to that in 1979?
Offer a terse response. 0.96. What is the ratio of the Female students (as % of total students) in Heavily indebted poor countries in 1978 to that in 1980?
Provide a succinct answer. 0.99. What is the ratio of the Female students (as % of total students) of Gabon in 1978 to that in 1980?
Your response must be concise. 0.97. What is the ratio of the Female students (as % of total students) in Grenada in 1978 to that in 1980?
Your answer should be compact. 1. What is the ratio of the Female students (as % of total students) of Libya in 1978 to that in 1980?
Ensure brevity in your answer.  0.93. What is the ratio of the Female students (as % of total students) of Heavily indebted poor countries in 1978 to that in 1981?
Provide a succinct answer. 0.98. What is the ratio of the Female students (as % of total students) of Gabon in 1978 to that in 1981?
Ensure brevity in your answer.  0.95. What is the ratio of the Female students (as % of total students) in Grenada in 1978 to that in 1981?
Keep it short and to the point. 0.93. What is the ratio of the Female students (as % of total students) in Libya in 1978 to that in 1981?
Give a very brief answer. 0.94. What is the ratio of the Female students (as % of total students) in Heavily indebted poor countries in 1978 to that in 1983?
Make the answer very short. 0.95. What is the ratio of the Female students (as % of total students) of Gabon in 1978 to that in 1983?
Give a very brief answer. 0.94. What is the ratio of the Female students (as % of total students) of Grenada in 1978 to that in 1983?
Your answer should be very brief. 0.95. What is the ratio of the Female students (as % of total students) in Libya in 1978 to that in 1983?
Ensure brevity in your answer.  0.9. What is the ratio of the Female students (as % of total students) in Heavily indebted poor countries in 1978 to that in 1986?
Your answer should be compact. 0.92. What is the ratio of the Female students (as % of total students) of Gabon in 1978 to that in 1986?
Ensure brevity in your answer.  0.91. What is the ratio of the Female students (as % of total students) of Grenada in 1978 to that in 1986?
Keep it short and to the point. 1.02. What is the ratio of the Female students (as % of total students) of Libya in 1978 to that in 1986?
Ensure brevity in your answer.  0.81. What is the ratio of the Female students (as % of total students) of Heavily indebted poor countries in 1979 to that in 1980?
Provide a succinct answer. 0.99. What is the ratio of the Female students (as % of total students) of Gabon in 1979 to that in 1980?
Keep it short and to the point. 0.97. What is the ratio of the Female students (as % of total students) in Libya in 1979 to that in 1980?
Provide a short and direct response. 0.97. What is the ratio of the Female students (as % of total students) of Heavily indebted poor countries in 1979 to that in 1981?
Your answer should be very brief. 0.98. What is the ratio of the Female students (as % of total students) of Gabon in 1979 to that in 1981?
Provide a short and direct response. 0.95. What is the ratio of the Female students (as % of total students) in Grenada in 1979 to that in 1981?
Your answer should be very brief. 0.93. What is the ratio of the Female students (as % of total students) of Libya in 1979 to that in 1981?
Offer a very short reply. 0.98. What is the ratio of the Female students (as % of total students) in Gabon in 1979 to that in 1983?
Offer a very short reply. 0.94. What is the ratio of the Female students (as % of total students) in Grenada in 1979 to that in 1983?
Give a very brief answer. 0.95. What is the ratio of the Female students (as % of total students) in Libya in 1979 to that in 1983?
Ensure brevity in your answer.  0.94. What is the ratio of the Female students (as % of total students) in Heavily indebted poor countries in 1979 to that in 1986?
Ensure brevity in your answer.  0.92. What is the ratio of the Female students (as % of total students) of Gabon in 1979 to that in 1986?
Give a very brief answer. 0.91. What is the ratio of the Female students (as % of total students) of Grenada in 1979 to that in 1986?
Offer a terse response. 1.02. What is the ratio of the Female students (as % of total students) in Libya in 1979 to that in 1986?
Offer a very short reply. 0.84. What is the ratio of the Female students (as % of total students) of Heavily indebted poor countries in 1980 to that in 1981?
Provide a short and direct response. 0.99. What is the ratio of the Female students (as % of total students) in Gabon in 1980 to that in 1981?
Your answer should be very brief. 0.98. What is the ratio of the Female students (as % of total students) in Grenada in 1980 to that in 1981?
Your answer should be compact. 0.93. What is the ratio of the Female students (as % of total students) of Libya in 1980 to that in 1981?
Make the answer very short. 1. What is the ratio of the Female students (as % of total students) of Heavily indebted poor countries in 1980 to that in 1983?
Ensure brevity in your answer.  0.96. What is the ratio of the Female students (as % of total students) of Gabon in 1980 to that in 1983?
Offer a very short reply. 0.97. What is the ratio of the Female students (as % of total students) in Grenada in 1980 to that in 1983?
Provide a succinct answer. 0.96. What is the ratio of the Female students (as % of total students) in Libya in 1980 to that in 1983?
Your response must be concise. 0.96. What is the ratio of the Female students (as % of total students) in Heavily indebted poor countries in 1980 to that in 1986?
Give a very brief answer. 0.93. What is the ratio of the Female students (as % of total students) in Gabon in 1980 to that in 1986?
Your answer should be very brief. 0.94. What is the ratio of the Female students (as % of total students) of Grenada in 1980 to that in 1986?
Ensure brevity in your answer.  1.02. What is the ratio of the Female students (as % of total students) of Libya in 1980 to that in 1986?
Your answer should be compact. 0.86. What is the ratio of the Female students (as % of total students) of Heavily indebted poor countries in 1981 to that in 1983?
Provide a short and direct response. 0.97. What is the ratio of the Female students (as % of total students) of Gabon in 1981 to that in 1983?
Make the answer very short. 0.99. What is the ratio of the Female students (as % of total students) in Grenada in 1981 to that in 1983?
Your answer should be very brief. 1.02. What is the ratio of the Female students (as % of total students) in Libya in 1981 to that in 1983?
Offer a terse response. 0.96. What is the ratio of the Female students (as % of total students) in Heavily indebted poor countries in 1981 to that in 1986?
Keep it short and to the point. 0.94. What is the ratio of the Female students (as % of total students) of Gabon in 1981 to that in 1986?
Provide a short and direct response. 0.96. What is the ratio of the Female students (as % of total students) of Grenada in 1981 to that in 1986?
Your answer should be compact. 1.1. What is the ratio of the Female students (as % of total students) of Libya in 1981 to that in 1986?
Offer a terse response. 0.86. What is the ratio of the Female students (as % of total students) in Heavily indebted poor countries in 1983 to that in 1986?
Your response must be concise. 0.97. What is the ratio of the Female students (as % of total students) of Gabon in 1983 to that in 1986?
Offer a very short reply. 0.97. What is the ratio of the Female students (as % of total students) in Grenada in 1983 to that in 1986?
Your response must be concise. 1.07. What is the ratio of the Female students (as % of total students) of Libya in 1983 to that in 1986?
Provide a short and direct response. 0.9. What is the difference between the highest and the second highest Female students (as % of total students) of Heavily indebted poor countries?
Ensure brevity in your answer.  1.17. What is the difference between the highest and the second highest Female students (as % of total students) of Gabon?
Your response must be concise. 1.32. What is the difference between the highest and the second highest Female students (as % of total students) in Grenada?
Offer a very short reply. 1.35. What is the difference between the highest and the second highest Female students (as % of total students) in Libya?
Your answer should be very brief. 4.61. What is the difference between the highest and the lowest Female students (as % of total students) of Heavily indebted poor countries?
Your answer should be compact. 3.14. What is the difference between the highest and the lowest Female students (as % of total students) in Gabon?
Your response must be concise. 5.34. What is the difference between the highest and the lowest Female students (as % of total students) of Grenada?
Ensure brevity in your answer.  5.22. What is the difference between the highest and the lowest Female students (as % of total students) in Libya?
Ensure brevity in your answer.  11.36. 